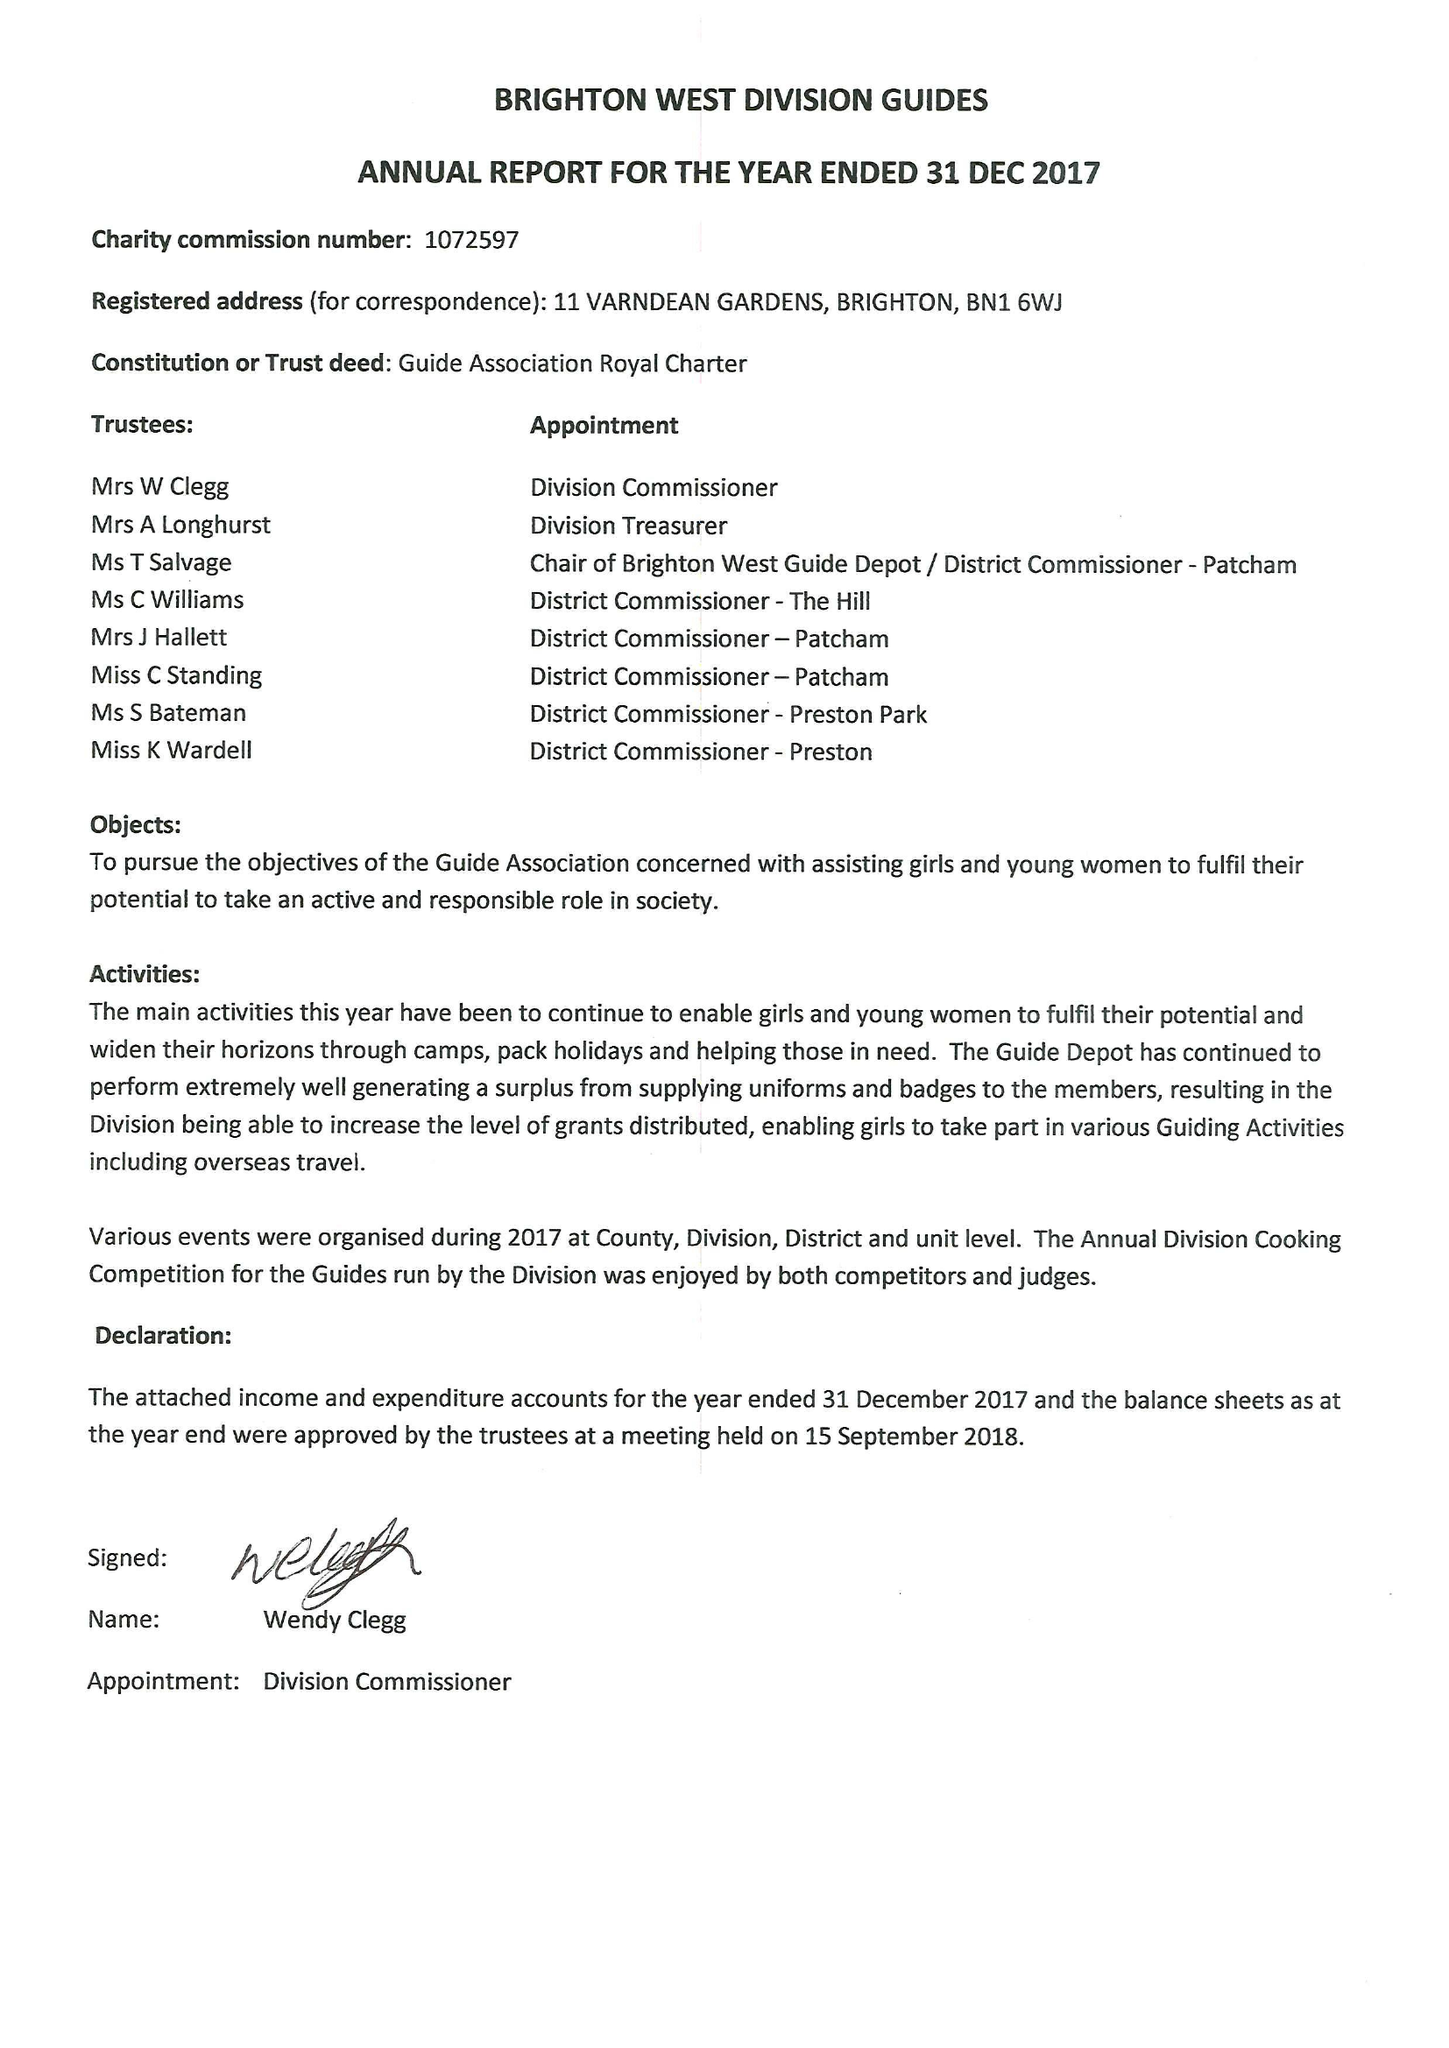What is the value for the charity_number?
Answer the question using a single word or phrase. 1072597 